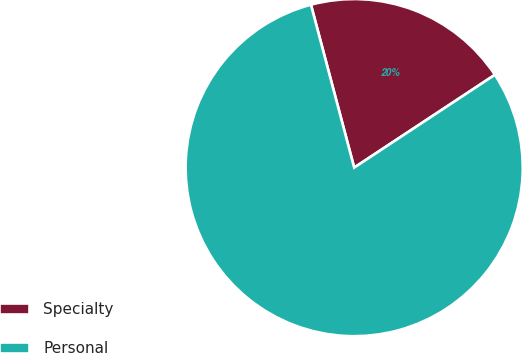Convert chart. <chart><loc_0><loc_0><loc_500><loc_500><pie_chart><fcel>Specialty<fcel>Personal<nl><fcel>19.85%<fcel>80.15%<nl></chart> 